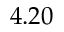Convert formula to latex. <formula><loc_0><loc_0><loc_500><loc_500>4 . 2 0</formula> 